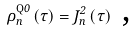Convert formula to latex. <formula><loc_0><loc_0><loc_500><loc_500>\rho _ { n } ^ { \text {Q} 0 } \left ( \tau \right ) = J _ { n } ^ { 2 } \left ( \tau \right ) \text { ,}</formula> 